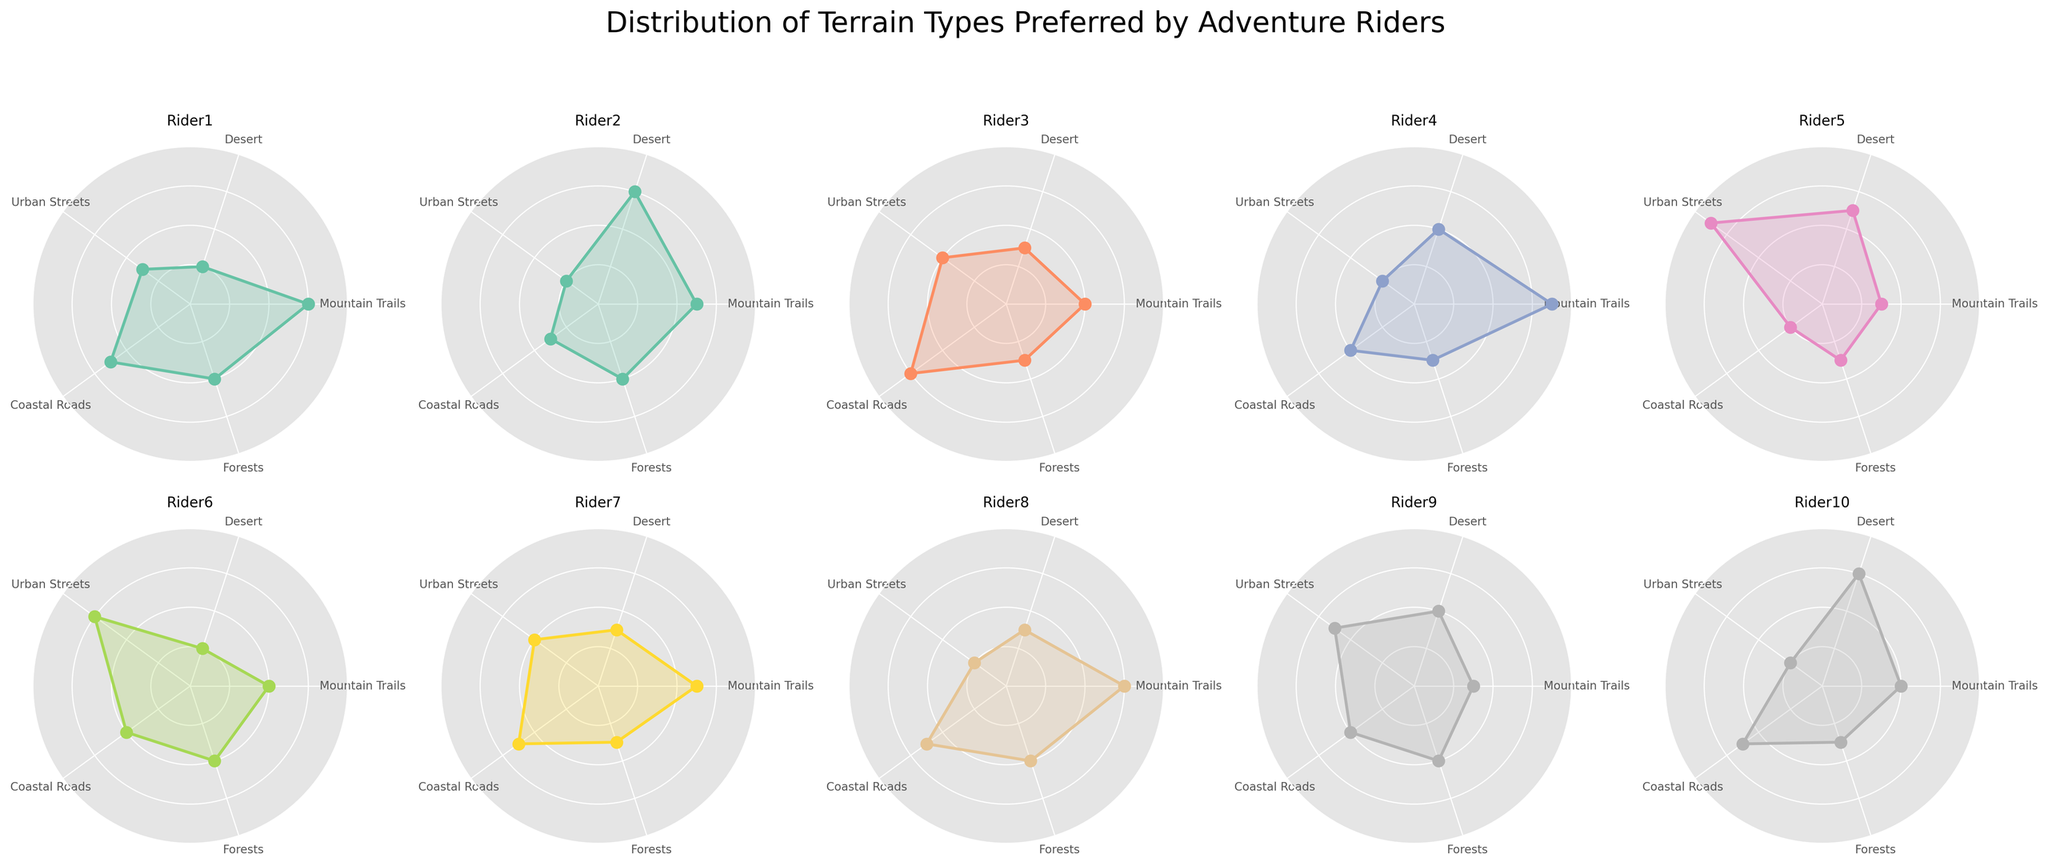What is the title of the chart? The title is usually located at the top of the chart and can be read easily. In this case, the title is clearly mentioned above all subplots.
Answer: Distribution of Terrain Types Preferred by Adventure Riders How many riders are represented in the chart? You can count the number of subplots or check the provided data to determine the number of riders, which matches the number of radar plots.
Answer: 10 Which rider has the highest preference for Coastal Roads? To identify this, look at each radar plot and find the one where the Coastal Roads axis has the highest value.
Answer: Alex Johnson Which terrain type has similar preferences among all riders? By observing the radar plots, an evenly distributed outer edge on a particular terrain type would indicate similar preferences among all riders.
Answer: Forests Which rider prefers Desert terrain the most? Look at each subplot to see the values on the Desert axis, and find the one with the highest value.
Answer: Jane Smith Is there any rider who prefers Urban Streets more than 30%? You need to check the Urban Streets values for each rider; if any radar plot has a value above 30 on the Urban Streets axis, that rider would be identified.
Answer: No On average, which terrain type is least preferred by the riders? Calculate the average value for each terrain type by adding the values for all riders and dividing by the number of riders. The terrain type with the lowest average value is the least preferred.
Answer: Urban Streets Comparing John Doe and Amy Clark, who prefers Mountain Trails more? Find the Mountain Trails values for both riders from their respective radar plots and compare them.
Answer: John Doe What is the difference in Desert preference between Laura Lee and James Miller? Observe the Desert values on the respective radar plots for Laura Lee and James Miller, and then calculate the difference.
Answer: -5 (20 - 15) Which rider has the most balanced terrain preferences across all terrain types? Look for the radar plot that appears most symmetrical, indicating a balanced distribution across all terrain axes.
Answer: David Wilson 